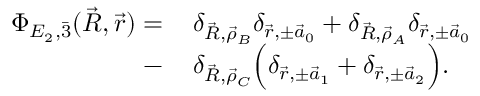Convert formula to latex. <formula><loc_0><loc_0><loc_500><loc_500>\begin{array} { r l } { \Phi _ { E _ { 2 } , \ B a r 3 } ( \vec { R } , \vec { r } ) = \, } & { \delta _ { \vec { R } , \vec { \rho } _ { B } } \delta _ { \vec { r } , \pm \vec { a } _ { 0 } } + \delta _ { \vec { R } , \vec { \rho } _ { A } } \delta _ { \vec { r } , \pm \vec { a } _ { 0 } } } \\ { - \, } & { \delta _ { \vec { R } , \vec { \rho } _ { C } } \left ( \delta _ { \vec { r } , \pm \vec { a } _ { 1 } } + \delta _ { \vec { r } , \pm \vec { a } _ { 2 } } \right ) . } \end{array}</formula> 